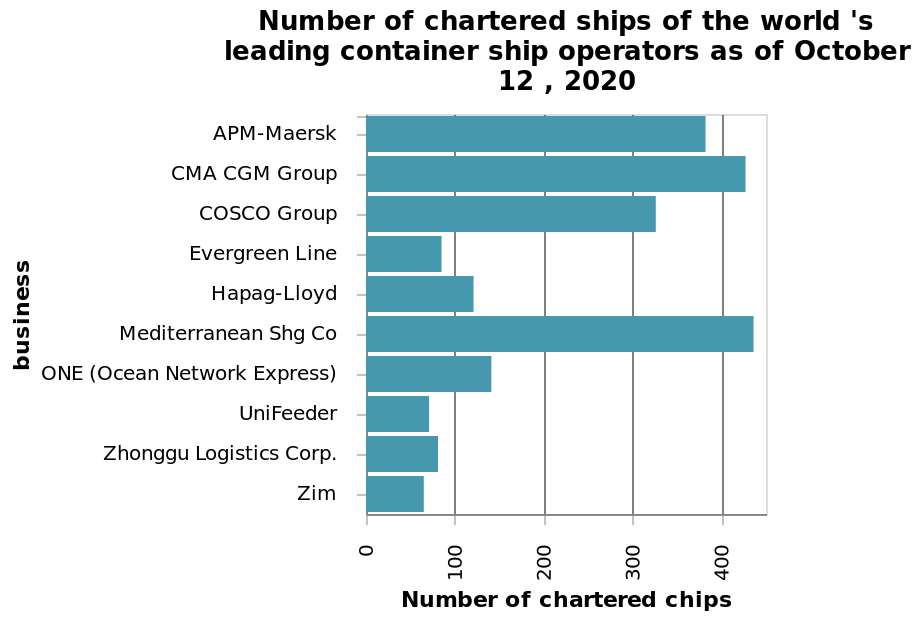<image>
What does the y-axis represent in the bar graph?  The y-axis represents the business of the world's leading container ship operators as of October 12, 2020. What is the date of the data represented in the bar graph?  The data represented in the bar graph is as of October 12, 2020. 